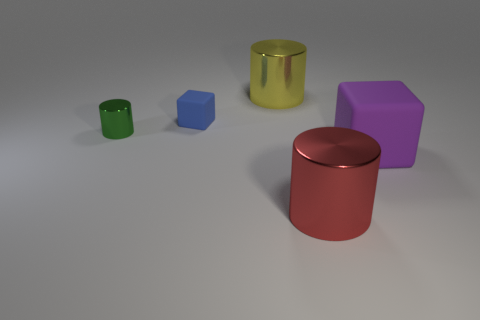The cylinder that is right of the green metallic object and to the left of the large red shiny thing is made of what material?
Provide a succinct answer. Metal. There is a metal thing that is to the left of the blue thing; what is its shape?
Your answer should be very brief. Cylinder. There is a large thing right of the metal cylinder in front of the green thing; what shape is it?
Keep it short and to the point. Cube. Is there another thing that has the same shape as the big red metallic object?
Your response must be concise. Yes. There is a purple object that is the same size as the yellow metallic object; what shape is it?
Offer a terse response. Cube. Is there a blue matte thing that is to the left of the block that is behind the shiny cylinder that is on the left side of the yellow cylinder?
Your answer should be very brief. No. Is there a red metallic cylinder of the same size as the green thing?
Give a very brief answer. No. There is a cylinder that is to the left of the tiny blue matte cube; what is its size?
Provide a short and direct response. Small. The matte thing that is in front of the matte block behind the thing that is right of the big red metal cylinder is what color?
Give a very brief answer. Purple. There is a large shiny cylinder to the left of the metallic cylinder in front of the big matte block; what is its color?
Provide a succinct answer. Yellow. 